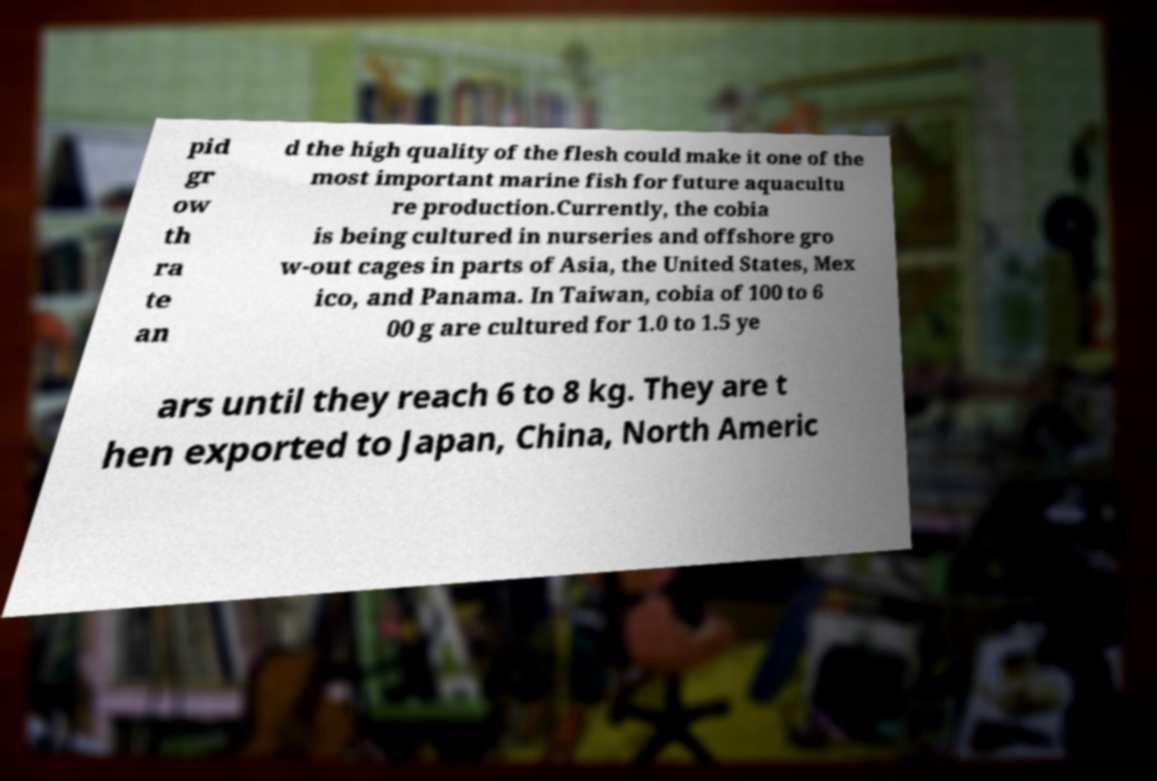Please identify and transcribe the text found in this image. pid gr ow th ra te an d the high quality of the flesh could make it one of the most important marine fish for future aquacultu re production.Currently, the cobia is being cultured in nurseries and offshore gro w-out cages in parts of Asia, the United States, Mex ico, and Panama. In Taiwan, cobia of 100 to 6 00 g are cultured for 1.0 to 1.5 ye ars until they reach 6 to 8 kg. They are t hen exported to Japan, China, North Americ 